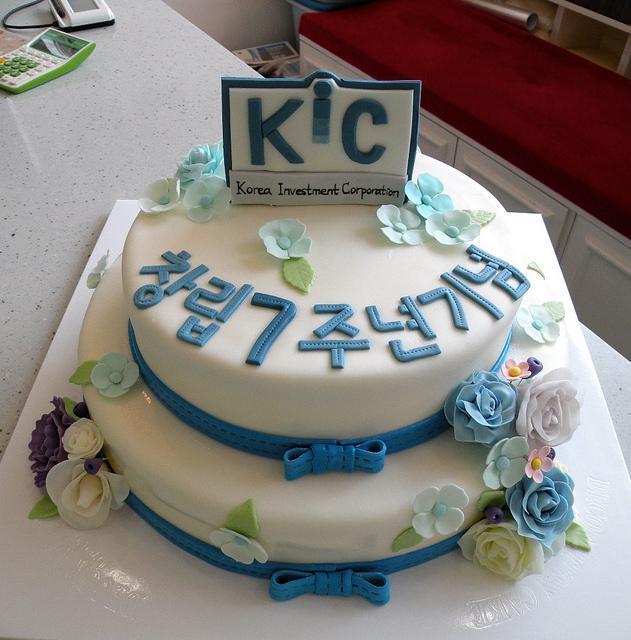How many layers are there?
Give a very brief answer. 2. 